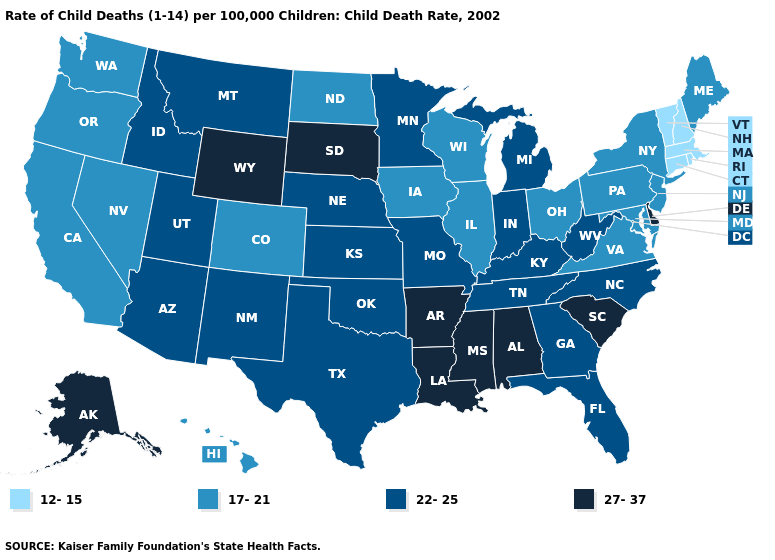Among the states that border Missouri , which have the highest value?
Concise answer only. Arkansas. What is the lowest value in the USA?
Quick response, please. 12-15. What is the value of Vermont?
Be succinct. 12-15. What is the value of South Carolina?
Keep it brief. 27-37. Name the states that have a value in the range 22-25?
Give a very brief answer. Arizona, Florida, Georgia, Idaho, Indiana, Kansas, Kentucky, Michigan, Minnesota, Missouri, Montana, Nebraska, New Mexico, North Carolina, Oklahoma, Tennessee, Texas, Utah, West Virginia. Does New Hampshire have a lower value than Michigan?
Write a very short answer. Yes. Name the states that have a value in the range 27-37?
Keep it brief. Alabama, Alaska, Arkansas, Delaware, Louisiana, Mississippi, South Carolina, South Dakota, Wyoming. What is the value of West Virginia?
Short answer required. 22-25. What is the value of West Virginia?
Quick response, please. 22-25. Which states hav the highest value in the West?
Give a very brief answer. Alaska, Wyoming. Does the first symbol in the legend represent the smallest category?
Short answer required. Yes. What is the highest value in states that border Illinois?
Short answer required. 22-25. Does Washington have the lowest value in the West?
Be succinct. Yes. Does the first symbol in the legend represent the smallest category?
Be succinct. Yes. Which states hav the highest value in the West?
Keep it brief. Alaska, Wyoming. 